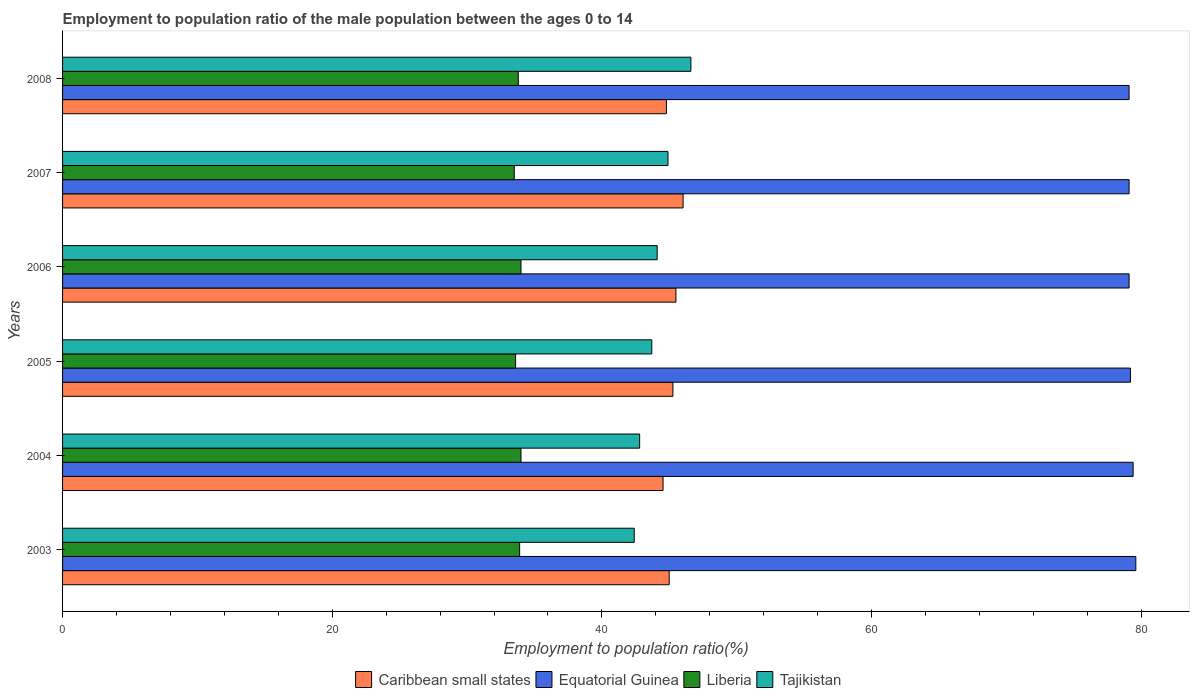How many different coloured bars are there?
Your answer should be compact. 4. Are the number of bars per tick equal to the number of legend labels?
Give a very brief answer. Yes. How many bars are there on the 1st tick from the top?
Provide a succinct answer. 4. How many bars are there on the 2nd tick from the bottom?
Ensure brevity in your answer.  4. What is the employment to population ratio in Liberia in 2008?
Give a very brief answer. 33.8. Across all years, what is the maximum employment to population ratio in Liberia?
Offer a very short reply. 34. Across all years, what is the minimum employment to population ratio in Liberia?
Your response must be concise. 33.5. What is the total employment to population ratio in Equatorial Guinea in the graph?
Provide a short and direct response. 475.5. What is the difference between the employment to population ratio in Caribbean small states in 2004 and that in 2007?
Your response must be concise. -1.49. What is the difference between the employment to population ratio in Equatorial Guinea in 2004 and the employment to population ratio in Liberia in 2005?
Make the answer very short. 45.8. What is the average employment to population ratio in Tajikistan per year?
Provide a short and direct response. 44.08. In the year 2005, what is the difference between the employment to population ratio in Equatorial Guinea and employment to population ratio in Caribbean small states?
Offer a terse response. 33.93. What is the ratio of the employment to population ratio in Caribbean small states in 2005 to that in 2008?
Give a very brief answer. 1.01. Is the employment to population ratio in Liberia in 2007 less than that in 2008?
Keep it short and to the point. Yes. What is the difference between the highest and the second highest employment to population ratio in Caribbean small states?
Provide a short and direct response. 0.53. What is the difference between the highest and the lowest employment to population ratio in Caribbean small states?
Ensure brevity in your answer.  1.49. What does the 4th bar from the top in 2004 represents?
Your answer should be very brief. Caribbean small states. What does the 1st bar from the bottom in 2003 represents?
Provide a succinct answer. Caribbean small states. How many bars are there?
Make the answer very short. 24. Are all the bars in the graph horizontal?
Your response must be concise. Yes. What is the difference between two consecutive major ticks on the X-axis?
Your answer should be very brief. 20. Does the graph contain any zero values?
Provide a succinct answer. No. Where does the legend appear in the graph?
Ensure brevity in your answer.  Bottom center. How many legend labels are there?
Ensure brevity in your answer.  4. What is the title of the graph?
Offer a very short reply. Employment to population ratio of the male population between the ages 0 to 14. What is the Employment to population ratio(%) in Caribbean small states in 2003?
Keep it short and to the point. 44.99. What is the Employment to population ratio(%) of Equatorial Guinea in 2003?
Give a very brief answer. 79.6. What is the Employment to population ratio(%) in Liberia in 2003?
Provide a short and direct response. 33.9. What is the Employment to population ratio(%) in Tajikistan in 2003?
Provide a short and direct response. 42.4. What is the Employment to population ratio(%) of Caribbean small states in 2004?
Your answer should be compact. 44.54. What is the Employment to population ratio(%) in Equatorial Guinea in 2004?
Your answer should be very brief. 79.4. What is the Employment to population ratio(%) in Liberia in 2004?
Make the answer very short. 34. What is the Employment to population ratio(%) of Tajikistan in 2004?
Ensure brevity in your answer.  42.8. What is the Employment to population ratio(%) in Caribbean small states in 2005?
Offer a terse response. 45.27. What is the Employment to population ratio(%) in Equatorial Guinea in 2005?
Provide a short and direct response. 79.2. What is the Employment to population ratio(%) in Liberia in 2005?
Offer a terse response. 33.6. What is the Employment to population ratio(%) of Tajikistan in 2005?
Keep it short and to the point. 43.7. What is the Employment to population ratio(%) of Caribbean small states in 2006?
Offer a terse response. 45.49. What is the Employment to population ratio(%) in Equatorial Guinea in 2006?
Provide a succinct answer. 79.1. What is the Employment to population ratio(%) in Tajikistan in 2006?
Ensure brevity in your answer.  44.1. What is the Employment to population ratio(%) in Caribbean small states in 2007?
Your answer should be very brief. 46.02. What is the Employment to population ratio(%) of Equatorial Guinea in 2007?
Provide a short and direct response. 79.1. What is the Employment to population ratio(%) of Liberia in 2007?
Your answer should be compact. 33.5. What is the Employment to population ratio(%) of Tajikistan in 2007?
Provide a succinct answer. 44.9. What is the Employment to population ratio(%) in Caribbean small states in 2008?
Offer a very short reply. 44.79. What is the Employment to population ratio(%) in Equatorial Guinea in 2008?
Your response must be concise. 79.1. What is the Employment to population ratio(%) of Liberia in 2008?
Ensure brevity in your answer.  33.8. What is the Employment to population ratio(%) in Tajikistan in 2008?
Provide a succinct answer. 46.6. Across all years, what is the maximum Employment to population ratio(%) of Caribbean small states?
Offer a terse response. 46.02. Across all years, what is the maximum Employment to population ratio(%) of Equatorial Guinea?
Offer a terse response. 79.6. Across all years, what is the maximum Employment to population ratio(%) of Liberia?
Your answer should be compact. 34. Across all years, what is the maximum Employment to population ratio(%) of Tajikistan?
Your answer should be compact. 46.6. Across all years, what is the minimum Employment to population ratio(%) in Caribbean small states?
Keep it short and to the point. 44.54. Across all years, what is the minimum Employment to population ratio(%) in Equatorial Guinea?
Your answer should be compact. 79.1. Across all years, what is the minimum Employment to population ratio(%) in Liberia?
Provide a short and direct response. 33.5. Across all years, what is the minimum Employment to population ratio(%) in Tajikistan?
Your answer should be very brief. 42.4. What is the total Employment to population ratio(%) in Caribbean small states in the graph?
Offer a terse response. 271.09. What is the total Employment to population ratio(%) of Equatorial Guinea in the graph?
Offer a very short reply. 475.5. What is the total Employment to population ratio(%) in Liberia in the graph?
Ensure brevity in your answer.  202.8. What is the total Employment to population ratio(%) of Tajikistan in the graph?
Make the answer very short. 264.5. What is the difference between the Employment to population ratio(%) of Caribbean small states in 2003 and that in 2004?
Your response must be concise. 0.45. What is the difference between the Employment to population ratio(%) in Liberia in 2003 and that in 2004?
Offer a very short reply. -0.1. What is the difference between the Employment to population ratio(%) in Caribbean small states in 2003 and that in 2005?
Give a very brief answer. -0.28. What is the difference between the Employment to population ratio(%) in Tajikistan in 2003 and that in 2005?
Your answer should be very brief. -1.3. What is the difference between the Employment to population ratio(%) in Caribbean small states in 2003 and that in 2006?
Keep it short and to the point. -0.5. What is the difference between the Employment to population ratio(%) of Equatorial Guinea in 2003 and that in 2006?
Your answer should be compact. 0.5. What is the difference between the Employment to population ratio(%) in Tajikistan in 2003 and that in 2006?
Ensure brevity in your answer.  -1.7. What is the difference between the Employment to population ratio(%) in Caribbean small states in 2003 and that in 2007?
Ensure brevity in your answer.  -1.03. What is the difference between the Employment to population ratio(%) of Equatorial Guinea in 2003 and that in 2007?
Your response must be concise. 0.5. What is the difference between the Employment to population ratio(%) in Liberia in 2003 and that in 2007?
Give a very brief answer. 0.4. What is the difference between the Employment to population ratio(%) of Tajikistan in 2003 and that in 2007?
Your answer should be compact. -2.5. What is the difference between the Employment to population ratio(%) of Caribbean small states in 2003 and that in 2008?
Provide a short and direct response. 0.2. What is the difference between the Employment to population ratio(%) in Equatorial Guinea in 2003 and that in 2008?
Your answer should be very brief. 0.5. What is the difference between the Employment to population ratio(%) in Caribbean small states in 2004 and that in 2005?
Keep it short and to the point. -0.73. What is the difference between the Employment to population ratio(%) in Equatorial Guinea in 2004 and that in 2005?
Offer a very short reply. 0.2. What is the difference between the Employment to population ratio(%) of Liberia in 2004 and that in 2005?
Offer a very short reply. 0.4. What is the difference between the Employment to population ratio(%) in Caribbean small states in 2004 and that in 2006?
Give a very brief answer. -0.96. What is the difference between the Employment to population ratio(%) in Liberia in 2004 and that in 2006?
Offer a terse response. 0. What is the difference between the Employment to population ratio(%) in Caribbean small states in 2004 and that in 2007?
Offer a terse response. -1.49. What is the difference between the Employment to population ratio(%) of Equatorial Guinea in 2004 and that in 2007?
Give a very brief answer. 0.3. What is the difference between the Employment to population ratio(%) in Tajikistan in 2004 and that in 2007?
Ensure brevity in your answer.  -2.1. What is the difference between the Employment to population ratio(%) in Caribbean small states in 2004 and that in 2008?
Ensure brevity in your answer.  -0.25. What is the difference between the Employment to population ratio(%) in Caribbean small states in 2005 and that in 2006?
Your answer should be very brief. -0.22. What is the difference between the Employment to population ratio(%) in Equatorial Guinea in 2005 and that in 2006?
Keep it short and to the point. 0.1. What is the difference between the Employment to population ratio(%) in Liberia in 2005 and that in 2006?
Your response must be concise. -0.4. What is the difference between the Employment to population ratio(%) of Tajikistan in 2005 and that in 2006?
Provide a short and direct response. -0.4. What is the difference between the Employment to population ratio(%) of Caribbean small states in 2005 and that in 2007?
Make the answer very short. -0.75. What is the difference between the Employment to population ratio(%) in Liberia in 2005 and that in 2007?
Give a very brief answer. 0.1. What is the difference between the Employment to population ratio(%) of Caribbean small states in 2005 and that in 2008?
Make the answer very short. 0.48. What is the difference between the Employment to population ratio(%) of Tajikistan in 2005 and that in 2008?
Offer a very short reply. -2.9. What is the difference between the Employment to population ratio(%) of Caribbean small states in 2006 and that in 2007?
Keep it short and to the point. -0.53. What is the difference between the Employment to population ratio(%) of Equatorial Guinea in 2006 and that in 2007?
Keep it short and to the point. 0. What is the difference between the Employment to population ratio(%) in Liberia in 2006 and that in 2007?
Offer a very short reply. 0.5. What is the difference between the Employment to population ratio(%) in Tajikistan in 2006 and that in 2007?
Your response must be concise. -0.8. What is the difference between the Employment to population ratio(%) in Caribbean small states in 2006 and that in 2008?
Your response must be concise. 0.7. What is the difference between the Employment to population ratio(%) of Caribbean small states in 2007 and that in 2008?
Your answer should be compact. 1.24. What is the difference between the Employment to population ratio(%) in Equatorial Guinea in 2007 and that in 2008?
Offer a terse response. 0. What is the difference between the Employment to population ratio(%) in Liberia in 2007 and that in 2008?
Keep it short and to the point. -0.3. What is the difference between the Employment to population ratio(%) of Caribbean small states in 2003 and the Employment to population ratio(%) of Equatorial Guinea in 2004?
Ensure brevity in your answer.  -34.41. What is the difference between the Employment to population ratio(%) in Caribbean small states in 2003 and the Employment to population ratio(%) in Liberia in 2004?
Offer a terse response. 10.99. What is the difference between the Employment to population ratio(%) of Caribbean small states in 2003 and the Employment to population ratio(%) of Tajikistan in 2004?
Give a very brief answer. 2.19. What is the difference between the Employment to population ratio(%) of Equatorial Guinea in 2003 and the Employment to population ratio(%) of Liberia in 2004?
Offer a terse response. 45.6. What is the difference between the Employment to population ratio(%) in Equatorial Guinea in 2003 and the Employment to population ratio(%) in Tajikistan in 2004?
Your answer should be compact. 36.8. What is the difference between the Employment to population ratio(%) in Caribbean small states in 2003 and the Employment to population ratio(%) in Equatorial Guinea in 2005?
Offer a terse response. -34.21. What is the difference between the Employment to population ratio(%) of Caribbean small states in 2003 and the Employment to population ratio(%) of Liberia in 2005?
Provide a succinct answer. 11.39. What is the difference between the Employment to population ratio(%) in Caribbean small states in 2003 and the Employment to population ratio(%) in Tajikistan in 2005?
Offer a terse response. 1.29. What is the difference between the Employment to population ratio(%) of Equatorial Guinea in 2003 and the Employment to population ratio(%) of Tajikistan in 2005?
Ensure brevity in your answer.  35.9. What is the difference between the Employment to population ratio(%) of Caribbean small states in 2003 and the Employment to population ratio(%) of Equatorial Guinea in 2006?
Provide a succinct answer. -34.11. What is the difference between the Employment to population ratio(%) of Caribbean small states in 2003 and the Employment to population ratio(%) of Liberia in 2006?
Ensure brevity in your answer.  10.99. What is the difference between the Employment to population ratio(%) in Caribbean small states in 2003 and the Employment to population ratio(%) in Tajikistan in 2006?
Keep it short and to the point. 0.89. What is the difference between the Employment to population ratio(%) of Equatorial Guinea in 2003 and the Employment to population ratio(%) of Liberia in 2006?
Your response must be concise. 45.6. What is the difference between the Employment to population ratio(%) in Equatorial Guinea in 2003 and the Employment to population ratio(%) in Tajikistan in 2006?
Your answer should be very brief. 35.5. What is the difference between the Employment to population ratio(%) of Liberia in 2003 and the Employment to population ratio(%) of Tajikistan in 2006?
Keep it short and to the point. -10.2. What is the difference between the Employment to population ratio(%) of Caribbean small states in 2003 and the Employment to population ratio(%) of Equatorial Guinea in 2007?
Give a very brief answer. -34.11. What is the difference between the Employment to population ratio(%) of Caribbean small states in 2003 and the Employment to population ratio(%) of Liberia in 2007?
Your answer should be compact. 11.49. What is the difference between the Employment to population ratio(%) in Caribbean small states in 2003 and the Employment to population ratio(%) in Tajikistan in 2007?
Offer a very short reply. 0.09. What is the difference between the Employment to population ratio(%) in Equatorial Guinea in 2003 and the Employment to population ratio(%) in Liberia in 2007?
Give a very brief answer. 46.1. What is the difference between the Employment to population ratio(%) in Equatorial Guinea in 2003 and the Employment to population ratio(%) in Tajikistan in 2007?
Provide a short and direct response. 34.7. What is the difference between the Employment to population ratio(%) in Liberia in 2003 and the Employment to population ratio(%) in Tajikistan in 2007?
Your answer should be compact. -11. What is the difference between the Employment to population ratio(%) in Caribbean small states in 2003 and the Employment to population ratio(%) in Equatorial Guinea in 2008?
Keep it short and to the point. -34.11. What is the difference between the Employment to population ratio(%) in Caribbean small states in 2003 and the Employment to population ratio(%) in Liberia in 2008?
Your answer should be compact. 11.19. What is the difference between the Employment to population ratio(%) in Caribbean small states in 2003 and the Employment to population ratio(%) in Tajikistan in 2008?
Keep it short and to the point. -1.61. What is the difference between the Employment to population ratio(%) of Equatorial Guinea in 2003 and the Employment to population ratio(%) of Liberia in 2008?
Your answer should be very brief. 45.8. What is the difference between the Employment to population ratio(%) of Liberia in 2003 and the Employment to population ratio(%) of Tajikistan in 2008?
Your response must be concise. -12.7. What is the difference between the Employment to population ratio(%) in Caribbean small states in 2004 and the Employment to population ratio(%) in Equatorial Guinea in 2005?
Make the answer very short. -34.66. What is the difference between the Employment to population ratio(%) of Caribbean small states in 2004 and the Employment to population ratio(%) of Liberia in 2005?
Make the answer very short. 10.94. What is the difference between the Employment to population ratio(%) in Caribbean small states in 2004 and the Employment to population ratio(%) in Tajikistan in 2005?
Ensure brevity in your answer.  0.84. What is the difference between the Employment to population ratio(%) in Equatorial Guinea in 2004 and the Employment to population ratio(%) in Liberia in 2005?
Your answer should be very brief. 45.8. What is the difference between the Employment to population ratio(%) of Equatorial Guinea in 2004 and the Employment to population ratio(%) of Tajikistan in 2005?
Your answer should be compact. 35.7. What is the difference between the Employment to population ratio(%) of Caribbean small states in 2004 and the Employment to population ratio(%) of Equatorial Guinea in 2006?
Give a very brief answer. -34.56. What is the difference between the Employment to population ratio(%) of Caribbean small states in 2004 and the Employment to population ratio(%) of Liberia in 2006?
Your answer should be compact. 10.54. What is the difference between the Employment to population ratio(%) of Caribbean small states in 2004 and the Employment to population ratio(%) of Tajikistan in 2006?
Your response must be concise. 0.44. What is the difference between the Employment to population ratio(%) in Equatorial Guinea in 2004 and the Employment to population ratio(%) in Liberia in 2006?
Your answer should be very brief. 45.4. What is the difference between the Employment to population ratio(%) in Equatorial Guinea in 2004 and the Employment to population ratio(%) in Tajikistan in 2006?
Ensure brevity in your answer.  35.3. What is the difference between the Employment to population ratio(%) in Caribbean small states in 2004 and the Employment to population ratio(%) in Equatorial Guinea in 2007?
Your response must be concise. -34.56. What is the difference between the Employment to population ratio(%) in Caribbean small states in 2004 and the Employment to population ratio(%) in Liberia in 2007?
Make the answer very short. 11.04. What is the difference between the Employment to population ratio(%) of Caribbean small states in 2004 and the Employment to population ratio(%) of Tajikistan in 2007?
Your answer should be compact. -0.36. What is the difference between the Employment to population ratio(%) in Equatorial Guinea in 2004 and the Employment to population ratio(%) in Liberia in 2007?
Keep it short and to the point. 45.9. What is the difference between the Employment to population ratio(%) of Equatorial Guinea in 2004 and the Employment to population ratio(%) of Tajikistan in 2007?
Your answer should be very brief. 34.5. What is the difference between the Employment to population ratio(%) of Caribbean small states in 2004 and the Employment to population ratio(%) of Equatorial Guinea in 2008?
Provide a succinct answer. -34.56. What is the difference between the Employment to population ratio(%) of Caribbean small states in 2004 and the Employment to population ratio(%) of Liberia in 2008?
Keep it short and to the point. 10.74. What is the difference between the Employment to population ratio(%) in Caribbean small states in 2004 and the Employment to population ratio(%) in Tajikistan in 2008?
Offer a very short reply. -2.06. What is the difference between the Employment to population ratio(%) of Equatorial Guinea in 2004 and the Employment to population ratio(%) of Liberia in 2008?
Offer a terse response. 45.6. What is the difference between the Employment to population ratio(%) of Equatorial Guinea in 2004 and the Employment to population ratio(%) of Tajikistan in 2008?
Make the answer very short. 32.8. What is the difference between the Employment to population ratio(%) in Liberia in 2004 and the Employment to population ratio(%) in Tajikistan in 2008?
Your answer should be very brief. -12.6. What is the difference between the Employment to population ratio(%) of Caribbean small states in 2005 and the Employment to population ratio(%) of Equatorial Guinea in 2006?
Provide a succinct answer. -33.83. What is the difference between the Employment to population ratio(%) of Caribbean small states in 2005 and the Employment to population ratio(%) of Liberia in 2006?
Provide a short and direct response. 11.27. What is the difference between the Employment to population ratio(%) in Caribbean small states in 2005 and the Employment to population ratio(%) in Tajikistan in 2006?
Keep it short and to the point. 1.17. What is the difference between the Employment to population ratio(%) in Equatorial Guinea in 2005 and the Employment to population ratio(%) in Liberia in 2006?
Provide a succinct answer. 45.2. What is the difference between the Employment to population ratio(%) of Equatorial Guinea in 2005 and the Employment to population ratio(%) of Tajikistan in 2006?
Offer a terse response. 35.1. What is the difference between the Employment to population ratio(%) of Caribbean small states in 2005 and the Employment to population ratio(%) of Equatorial Guinea in 2007?
Provide a short and direct response. -33.83. What is the difference between the Employment to population ratio(%) in Caribbean small states in 2005 and the Employment to population ratio(%) in Liberia in 2007?
Offer a very short reply. 11.77. What is the difference between the Employment to population ratio(%) in Caribbean small states in 2005 and the Employment to population ratio(%) in Tajikistan in 2007?
Provide a short and direct response. 0.37. What is the difference between the Employment to population ratio(%) in Equatorial Guinea in 2005 and the Employment to population ratio(%) in Liberia in 2007?
Your response must be concise. 45.7. What is the difference between the Employment to population ratio(%) in Equatorial Guinea in 2005 and the Employment to population ratio(%) in Tajikistan in 2007?
Ensure brevity in your answer.  34.3. What is the difference between the Employment to population ratio(%) of Caribbean small states in 2005 and the Employment to population ratio(%) of Equatorial Guinea in 2008?
Your answer should be very brief. -33.83. What is the difference between the Employment to population ratio(%) in Caribbean small states in 2005 and the Employment to population ratio(%) in Liberia in 2008?
Offer a terse response. 11.47. What is the difference between the Employment to population ratio(%) of Caribbean small states in 2005 and the Employment to population ratio(%) of Tajikistan in 2008?
Your response must be concise. -1.33. What is the difference between the Employment to population ratio(%) in Equatorial Guinea in 2005 and the Employment to population ratio(%) in Liberia in 2008?
Keep it short and to the point. 45.4. What is the difference between the Employment to population ratio(%) in Equatorial Guinea in 2005 and the Employment to population ratio(%) in Tajikistan in 2008?
Offer a terse response. 32.6. What is the difference between the Employment to population ratio(%) in Caribbean small states in 2006 and the Employment to population ratio(%) in Equatorial Guinea in 2007?
Your answer should be very brief. -33.61. What is the difference between the Employment to population ratio(%) in Caribbean small states in 2006 and the Employment to population ratio(%) in Liberia in 2007?
Offer a very short reply. 11.99. What is the difference between the Employment to population ratio(%) in Caribbean small states in 2006 and the Employment to population ratio(%) in Tajikistan in 2007?
Your response must be concise. 0.59. What is the difference between the Employment to population ratio(%) in Equatorial Guinea in 2006 and the Employment to population ratio(%) in Liberia in 2007?
Provide a succinct answer. 45.6. What is the difference between the Employment to population ratio(%) in Equatorial Guinea in 2006 and the Employment to population ratio(%) in Tajikistan in 2007?
Give a very brief answer. 34.2. What is the difference between the Employment to population ratio(%) of Caribbean small states in 2006 and the Employment to population ratio(%) of Equatorial Guinea in 2008?
Your response must be concise. -33.61. What is the difference between the Employment to population ratio(%) of Caribbean small states in 2006 and the Employment to population ratio(%) of Liberia in 2008?
Provide a short and direct response. 11.69. What is the difference between the Employment to population ratio(%) of Caribbean small states in 2006 and the Employment to population ratio(%) of Tajikistan in 2008?
Keep it short and to the point. -1.11. What is the difference between the Employment to population ratio(%) in Equatorial Guinea in 2006 and the Employment to population ratio(%) in Liberia in 2008?
Provide a succinct answer. 45.3. What is the difference between the Employment to population ratio(%) of Equatorial Guinea in 2006 and the Employment to population ratio(%) of Tajikistan in 2008?
Make the answer very short. 32.5. What is the difference between the Employment to population ratio(%) in Liberia in 2006 and the Employment to population ratio(%) in Tajikistan in 2008?
Keep it short and to the point. -12.6. What is the difference between the Employment to population ratio(%) in Caribbean small states in 2007 and the Employment to population ratio(%) in Equatorial Guinea in 2008?
Keep it short and to the point. -33.08. What is the difference between the Employment to population ratio(%) of Caribbean small states in 2007 and the Employment to population ratio(%) of Liberia in 2008?
Make the answer very short. 12.22. What is the difference between the Employment to population ratio(%) in Caribbean small states in 2007 and the Employment to population ratio(%) in Tajikistan in 2008?
Ensure brevity in your answer.  -0.58. What is the difference between the Employment to population ratio(%) of Equatorial Guinea in 2007 and the Employment to population ratio(%) of Liberia in 2008?
Offer a terse response. 45.3. What is the difference between the Employment to population ratio(%) in Equatorial Guinea in 2007 and the Employment to population ratio(%) in Tajikistan in 2008?
Give a very brief answer. 32.5. What is the average Employment to population ratio(%) in Caribbean small states per year?
Offer a very short reply. 45.18. What is the average Employment to population ratio(%) of Equatorial Guinea per year?
Keep it short and to the point. 79.25. What is the average Employment to population ratio(%) in Liberia per year?
Make the answer very short. 33.8. What is the average Employment to population ratio(%) in Tajikistan per year?
Your response must be concise. 44.08. In the year 2003, what is the difference between the Employment to population ratio(%) of Caribbean small states and Employment to population ratio(%) of Equatorial Guinea?
Your answer should be very brief. -34.61. In the year 2003, what is the difference between the Employment to population ratio(%) of Caribbean small states and Employment to population ratio(%) of Liberia?
Your answer should be compact. 11.09. In the year 2003, what is the difference between the Employment to population ratio(%) in Caribbean small states and Employment to population ratio(%) in Tajikistan?
Your answer should be very brief. 2.59. In the year 2003, what is the difference between the Employment to population ratio(%) of Equatorial Guinea and Employment to population ratio(%) of Liberia?
Offer a terse response. 45.7. In the year 2003, what is the difference between the Employment to population ratio(%) of Equatorial Guinea and Employment to population ratio(%) of Tajikistan?
Offer a very short reply. 37.2. In the year 2004, what is the difference between the Employment to population ratio(%) of Caribbean small states and Employment to population ratio(%) of Equatorial Guinea?
Provide a short and direct response. -34.86. In the year 2004, what is the difference between the Employment to population ratio(%) of Caribbean small states and Employment to population ratio(%) of Liberia?
Your answer should be very brief. 10.54. In the year 2004, what is the difference between the Employment to population ratio(%) in Caribbean small states and Employment to population ratio(%) in Tajikistan?
Keep it short and to the point. 1.74. In the year 2004, what is the difference between the Employment to population ratio(%) in Equatorial Guinea and Employment to population ratio(%) in Liberia?
Your response must be concise. 45.4. In the year 2004, what is the difference between the Employment to population ratio(%) of Equatorial Guinea and Employment to population ratio(%) of Tajikistan?
Your answer should be very brief. 36.6. In the year 2005, what is the difference between the Employment to population ratio(%) of Caribbean small states and Employment to population ratio(%) of Equatorial Guinea?
Your answer should be very brief. -33.93. In the year 2005, what is the difference between the Employment to population ratio(%) in Caribbean small states and Employment to population ratio(%) in Liberia?
Offer a terse response. 11.67. In the year 2005, what is the difference between the Employment to population ratio(%) of Caribbean small states and Employment to population ratio(%) of Tajikistan?
Ensure brevity in your answer.  1.57. In the year 2005, what is the difference between the Employment to population ratio(%) in Equatorial Guinea and Employment to population ratio(%) in Liberia?
Your response must be concise. 45.6. In the year 2005, what is the difference between the Employment to population ratio(%) of Equatorial Guinea and Employment to population ratio(%) of Tajikistan?
Your answer should be very brief. 35.5. In the year 2006, what is the difference between the Employment to population ratio(%) of Caribbean small states and Employment to population ratio(%) of Equatorial Guinea?
Keep it short and to the point. -33.61. In the year 2006, what is the difference between the Employment to population ratio(%) in Caribbean small states and Employment to population ratio(%) in Liberia?
Ensure brevity in your answer.  11.49. In the year 2006, what is the difference between the Employment to population ratio(%) in Caribbean small states and Employment to population ratio(%) in Tajikistan?
Keep it short and to the point. 1.39. In the year 2006, what is the difference between the Employment to population ratio(%) in Equatorial Guinea and Employment to population ratio(%) in Liberia?
Provide a succinct answer. 45.1. In the year 2006, what is the difference between the Employment to population ratio(%) in Liberia and Employment to population ratio(%) in Tajikistan?
Offer a terse response. -10.1. In the year 2007, what is the difference between the Employment to population ratio(%) in Caribbean small states and Employment to population ratio(%) in Equatorial Guinea?
Keep it short and to the point. -33.08. In the year 2007, what is the difference between the Employment to population ratio(%) in Caribbean small states and Employment to population ratio(%) in Liberia?
Provide a short and direct response. 12.52. In the year 2007, what is the difference between the Employment to population ratio(%) in Caribbean small states and Employment to population ratio(%) in Tajikistan?
Ensure brevity in your answer.  1.12. In the year 2007, what is the difference between the Employment to population ratio(%) in Equatorial Guinea and Employment to population ratio(%) in Liberia?
Offer a terse response. 45.6. In the year 2007, what is the difference between the Employment to population ratio(%) of Equatorial Guinea and Employment to population ratio(%) of Tajikistan?
Your answer should be very brief. 34.2. In the year 2007, what is the difference between the Employment to population ratio(%) of Liberia and Employment to population ratio(%) of Tajikistan?
Make the answer very short. -11.4. In the year 2008, what is the difference between the Employment to population ratio(%) in Caribbean small states and Employment to population ratio(%) in Equatorial Guinea?
Ensure brevity in your answer.  -34.31. In the year 2008, what is the difference between the Employment to population ratio(%) of Caribbean small states and Employment to population ratio(%) of Liberia?
Your answer should be very brief. 10.99. In the year 2008, what is the difference between the Employment to population ratio(%) of Caribbean small states and Employment to population ratio(%) of Tajikistan?
Your answer should be compact. -1.81. In the year 2008, what is the difference between the Employment to population ratio(%) of Equatorial Guinea and Employment to population ratio(%) of Liberia?
Make the answer very short. 45.3. In the year 2008, what is the difference between the Employment to population ratio(%) of Equatorial Guinea and Employment to population ratio(%) of Tajikistan?
Your response must be concise. 32.5. In the year 2008, what is the difference between the Employment to population ratio(%) in Liberia and Employment to population ratio(%) in Tajikistan?
Give a very brief answer. -12.8. What is the ratio of the Employment to population ratio(%) of Caribbean small states in 2003 to that in 2004?
Provide a short and direct response. 1.01. What is the ratio of the Employment to population ratio(%) of Liberia in 2003 to that in 2004?
Keep it short and to the point. 1. What is the ratio of the Employment to population ratio(%) of Tajikistan in 2003 to that in 2004?
Your response must be concise. 0.99. What is the ratio of the Employment to population ratio(%) of Liberia in 2003 to that in 2005?
Ensure brevity in your answer.  1.01. What is the ratio of the Employment to population ratio(%) in Tajikistan in 2003 to that in 2005?
Ensure brevity in your answer.  0.97. What is the ratio of the Employment to population ratio(%) in Tajikistan in 2003 to that in 2006?
Offer a very short reply. 0.96. What is the ratio of the Employment to population ratio(%) of Caribbean small states in 2003 to that in 2007?
Ensure brevity in your answer.  0.98. What is the ratio of the Employment to population ratio(%) in Liberia in 2003 to that in 2007?
Ensure brevity in your answer.  1.01. What is the ratio of the Employment to population ratio(%) in Tajikistan in 2003 to that in 2007?
Keep it short and to the point. 0.94. What is the ratio of the Employment to population ratio(%) of Caribbean small states in 2003 to that in 2008?
Provide a short and direct response. 1. What is the ratio of the Employment to population ratio(%) in Equatorial Guinea in 2003 to that in 2008?
Provide a succinct answer. 1.01. What is the ratio of the Employment to population ratio(%) of Liberia in 2003 to that in 2008?
Offer a very short reply. 1. What is the ratio of the Employment to population ratio(%) in Tajikistan in 2003 to that in 2008?
Make the answer very short. 0.91. What is the ratio of the Employment to population ratio(%) of Caribbean small states in 2004 to that in 2005?
Your answer should be very brief. 0.98. What is the ratio of the Employment to population ratio(%) of Liberia in 2004 to that in 2005?
Offer a very short reply. 1.01. What is the ratio of the Employment to population ratio(%) in Tajikistan in 2004 to that in 2005?
Give a very brief answer. 0.98. What is the ratio of the Employment to population ratio(%) of Tajikistan in 2004 to that in 2006?
Make the answer very short. 0.97. What is the ratio of the Employment to population ratio(%) in Caribbean small states in 2004 to that in 2007?
Offer a very short reply. 0.97. What is the ratio of the Employment to population ratio(%) in Equatorial Guinea in 2004 to that in 2007?
Keep it short and to the point. 1. What is the ratio of the Employment to population ratio(%) of Liberia in 2004 to that in 2007?
Provide a short and direct response. 1.01. What is the ratio of the Employment to population ratio(%) of Tajikistan in 2004 to that in 2007?
Ensure brevity in your answer.  0.95. What is the ratio of the Employment to population ratio(%) in Liberia in 2004 to that in 2008?
Keep it short and to the point. 1.01. What is the ratio of the Employment to population ratio(%) of Tajikistan in 2004 to that in 2008?
Keep it short and to the point. 0.92. What is the ratio of the Employment to population ratio(%) of Equatorial Guinea in 2005 to that in 2006?
Make the answer very short. 1. What is the ratio of the Employment to population ratio(%) of Liberia in 2005 to that in 2006?
Offer a terse response. 0.99. What is the ratio of the Employment to population ratio(%) in Tajikistan in 2005 to that in 2006?
Make the answer very short. 0.99. What is the ratio of the Employment to population ratio(%) in Caribbean small states in 2005 to that in 2007?
Your answer should be compact. 0.98. What is the ratio of the Employment to population ratio(%) of Equatorial Guinea in 2005 to that in 2007?
Make the answer very short. 1. What is the ratio of the Employment to population ratio(%) in Liberia in 2005 to that in 2007?
Your response must be concise. 1. What is the ratio of the Employment to population ratio(%) of Tajikistan in 2005 to that in 2007?
Keep it short and to the point. 0.97. What is the ratio of the Employment to population ratio(%) in Caribbean small states in 2005 to that in 2008?
Offer a terse response. 1.01. What is the ratio of the Employment to population ratio(%) in Equatorial Guinea in 2005 to that in 2008?
Provide a succinct answer. 1. What is the ratio of the Employment to population ratio(%) in Tajikistan in 2005 to that in 2008?
Provide a succinct answer. 0.94. What is the ratio of the Employment to population ratio(%) of Caribbean small states in 2006 to that in 2007?
Your response must be concise. 0.99. What is the ratio of the Employment to population ratio(%) of Liberia in 2006 to that in 2007?
Your response must be concise. 1.01. What is the ratio of the Employment to population ratio(%) of Tajikistan in 2006 to that in 2007?
Provide a succinct answer. 0.98. What is the ratio of the Employment to population ratio(%) in Caribbean small states in 2006 to that in 2008?
Make the answer very short. 1.02. What is the ratio of the Employment to population ratio(%) in Liberia in 2006 to that in 2008?
Give a very brief answer. 1.01. What is the ratio of the Employment to population ratio(%) in Tajikistan in 2006 to that in 2008?
Offer a very short reply. 0.95. What is the ratio of the Employment to population ratio(%) of Caribbean small states in 2007 to that in 2008?
Offer a terse response. 1.03. What is the ratio of the Employment to population ratio(%) of Equatorial Guinea in 2007 to that in 2008?
Your response must be concise. 1. What is the ratio of the Employment to population ratio(%) of Liberia in 2007 to that in 2008?
Provide a succinct answer. 0.99. What is the ratio of the Employment to population ratio(%) in Tajikistan in 2007 to that in 2008?
Make the answer very short. 0.96. What is the difference between the highest and the second highest Employment to population ratio(%) of Caribbean small states?
Your answer should be very brief. 0.53. What is the difference between the highest and the second highest Employment to population ratio(%) of Tajikistan?
Ensure brevity in your answer.  1.7. What is the difference between the highest and the lowest Employment to population ratio(%) in Caribbean small states?
Provide a short and direct response. 1.49. What is the difference between the highest and the lowest Employment to population ratio(%) in Equatorial Guinea?
Provide a succinct answer. 0.5. What is the difference between the highest and the lowest Employment to population ratio(%) of Tajikistan?
Offer a terse response. 4.2. 